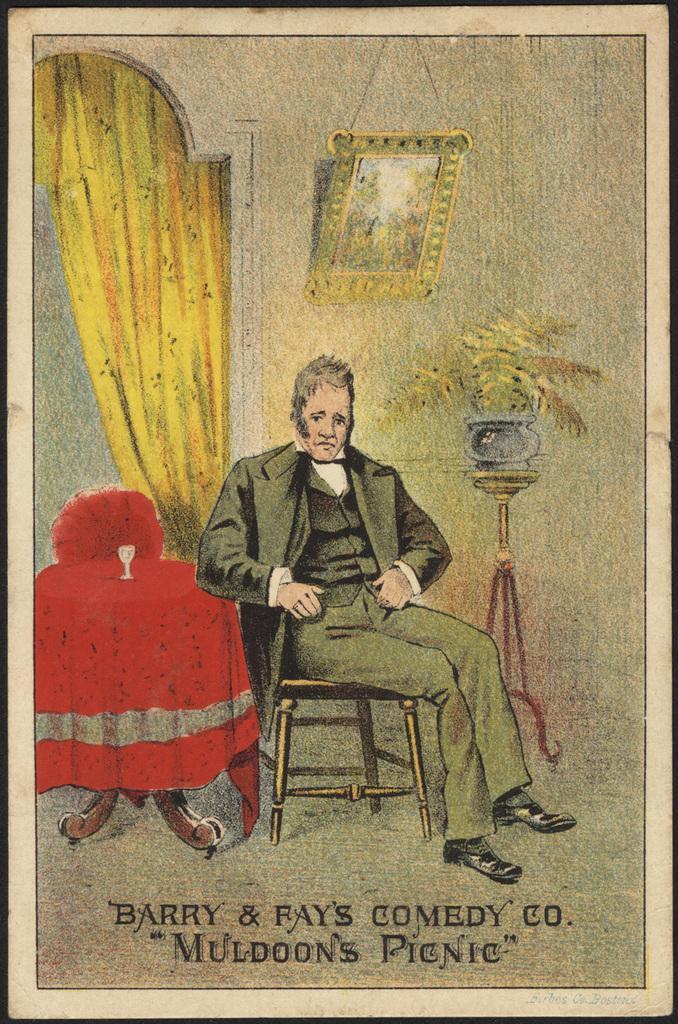In one or two sentences, can you explain what this image depicts? In this image there is one photo frame, in the photo frame there is painting and in the center there is one person who is sitting on chair. Beside him there is a table and chair, and on the right side there is a flower pot, plant and on the wall there is a photo frame. On the left side there is a curtain, and at the bottom of the image there is some text. 